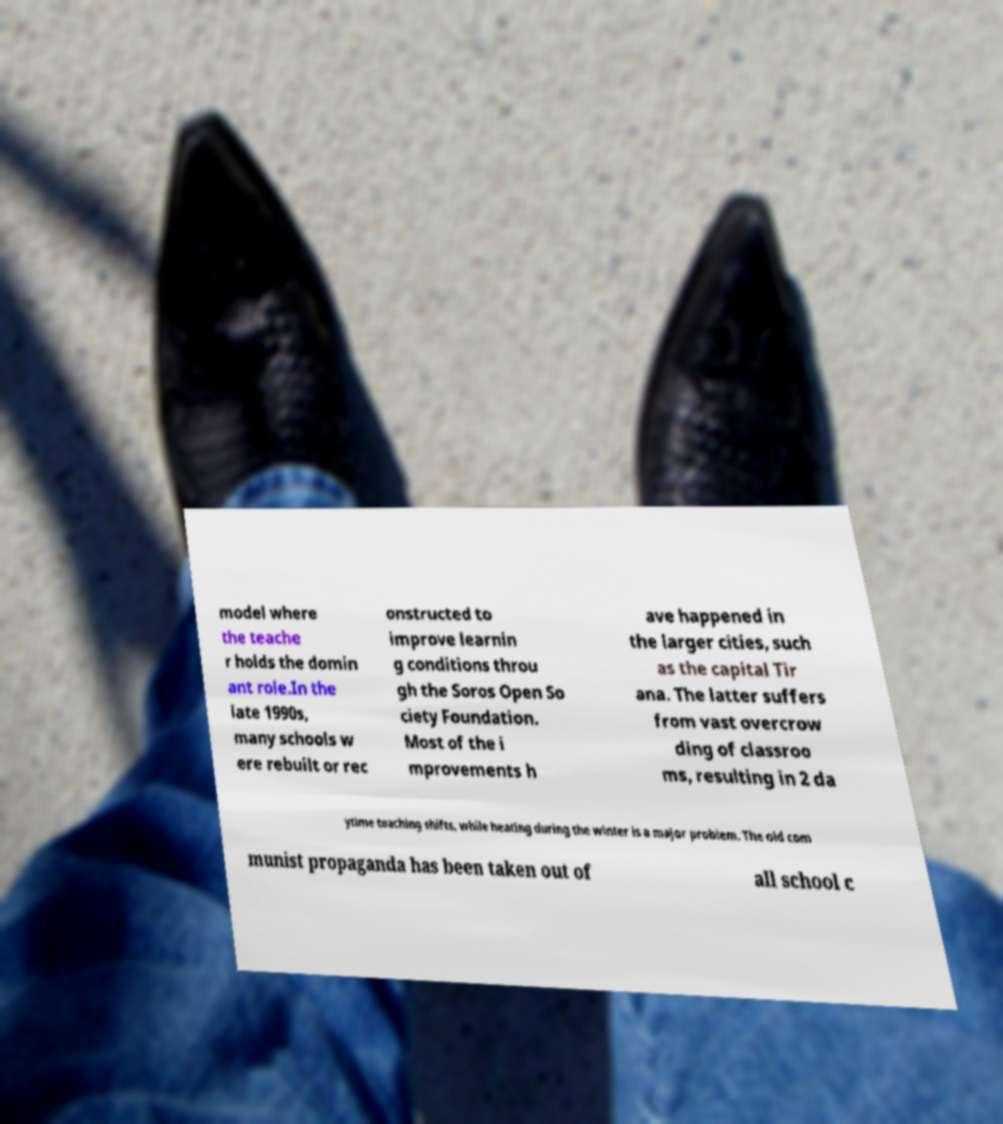Can you accurately transcribe the text from the provided image for me? model where the teache r holds the domin ant role.In the late 1990s, many schools w ere rebuilt or rec onstructed to improve learnin g conditions throu gh the Soros Open So ciety Foundation. Most of the i mprovements h ave happened in the larger cities, such as the capital Tir ana. The latter suffers from vast overcrow ding of classroo ms, resulting in 2 da ytime teaching shifts, while heating during the winter is a major problem. The old com munist propaganda has been taken out of all school c 